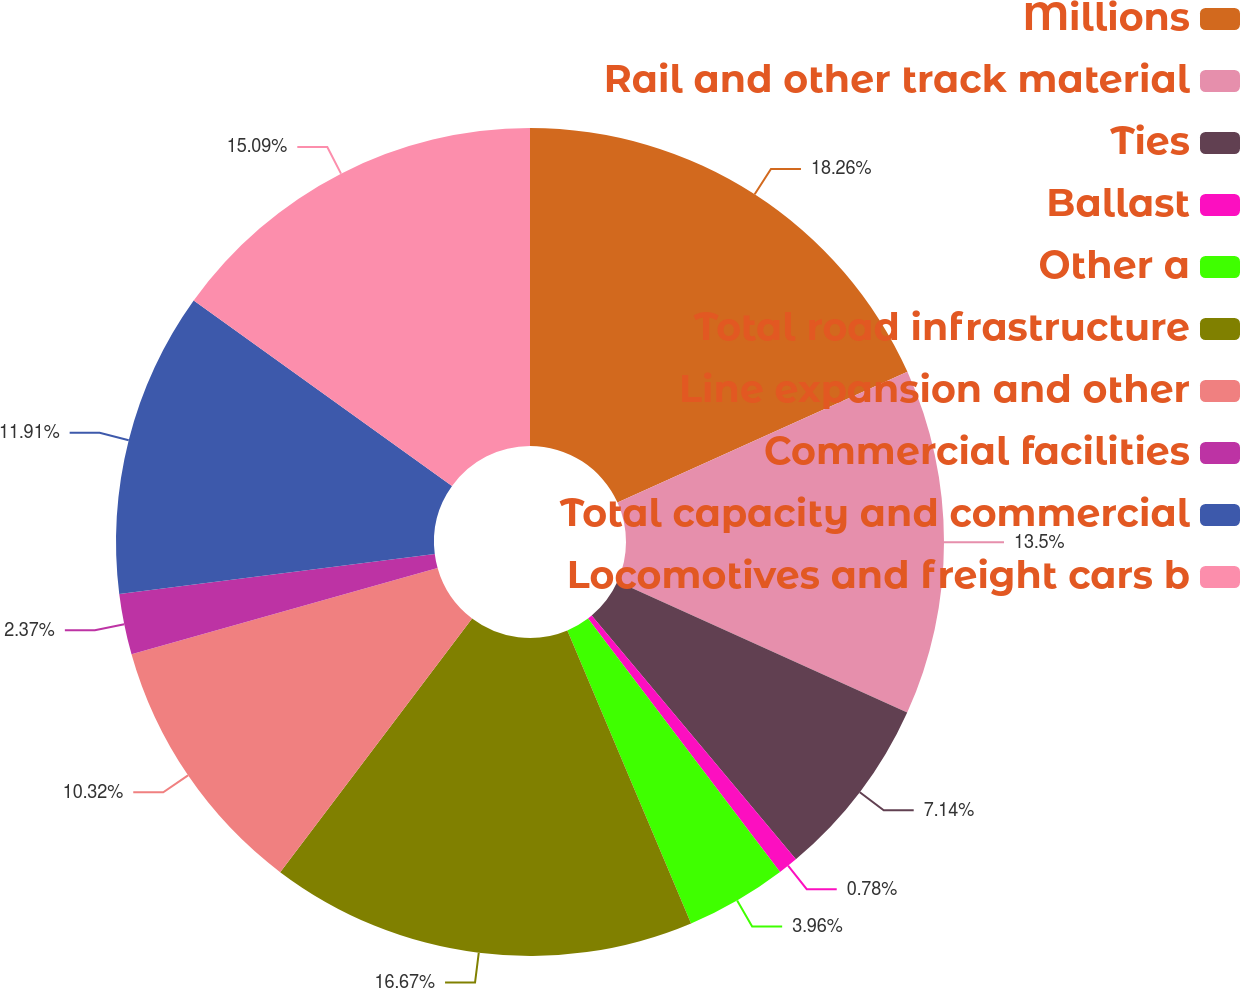Convert chart to OTSL. <chart><loc_0><loc_0><loc_500><loc_500><pie_chart><fcel>Millions<fcel>Rail and other track material<fcel>Ties<fcel>Ballast<fcel>Other a<fcel>Total road infrastructure<fcel>Line expansion and other<fcel>Commercial facilities<fcel>Total capacity and commercial<fcel>Locomotives and freight cars b<nl><fcel>18.26%<fcel>13.5%<fcel>7.14%<fcel>0.78%<fcel>3.96%<fcel>16.67%<fcel>10.32%<fcel>2.37%<fcel>11.91%<fcel>15.09%<nl></chart> 